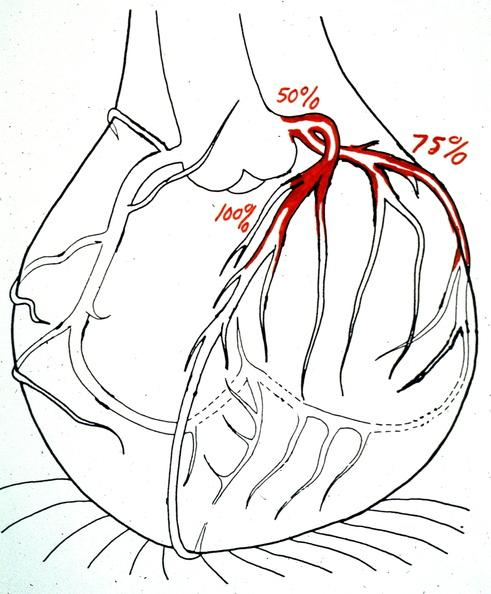where is this area in the body?
Answer the question using a single word or phrase. Heart 